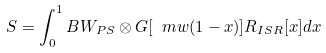Convert formula to latex. <formula><loc_0><loc_0><loc_500><loc_500>S = \int _ { 0 } ^ { 1 } B W _ { P S } \otimes G [ \ m w ( 1 - x ) ] R _ { I S R } [ x ] d x</formula> 